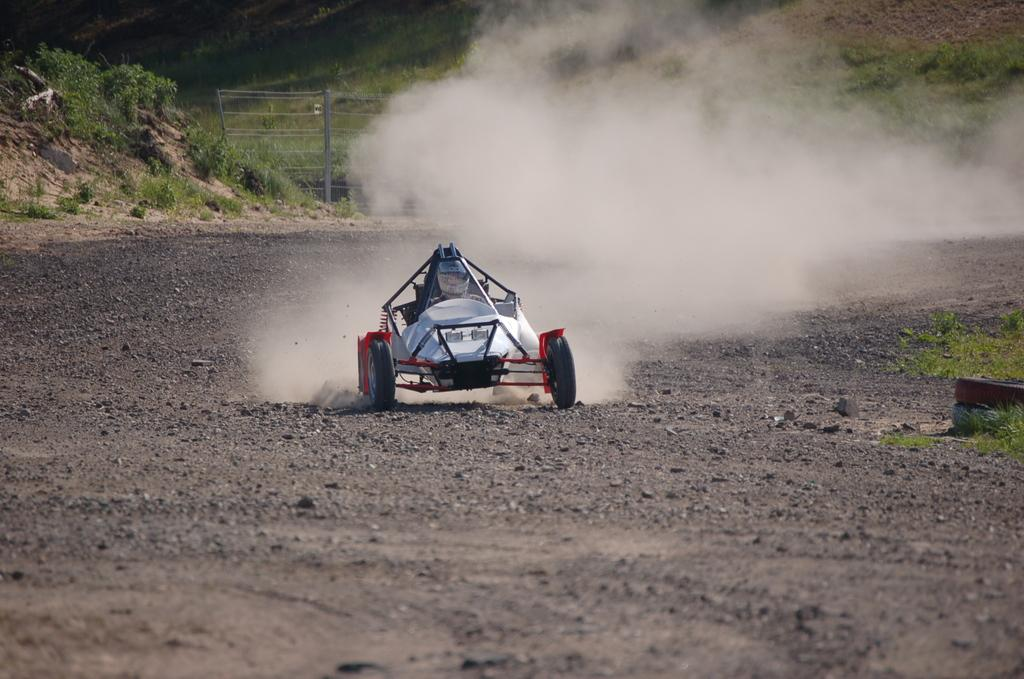What is the main subject of the image? The main subject of the image is a racing car. What is the racing car doing in the image? The racing car is moving on the ground in the image. What can be seen in the background of the image? There are trees in the background of the image. What type of terrain is visible in the front of the image? There is grass on the ground in the front of the image. What month is depicted in the image? The image does not depict a specific month; it only shows a racing car moving on the ground with trees and grass in the background. What type of cap is the racing car driver wearing in the image? There is no racing car driver visible in the image, so it is impossible to determine what type of cap they might be wearing. 